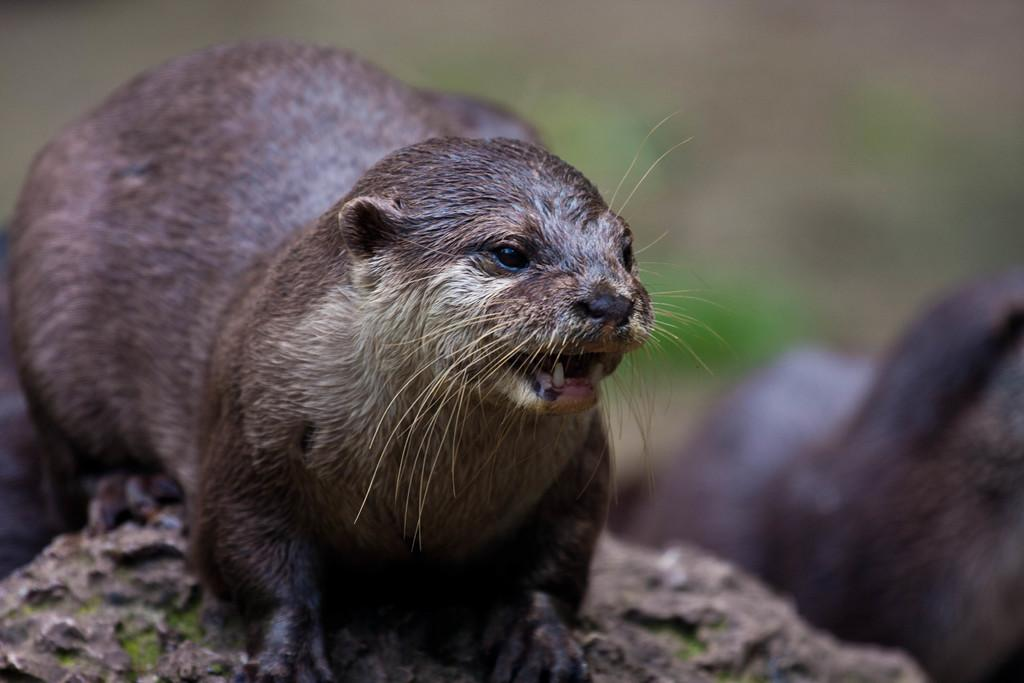What is the main subject of the image? There is an animal on a rock in the image. Can you describe the setting of the image? The background of the image is blurred. What type of attraction can be seen in the background of the image? There is no attraction visible in the image; the background is blurred. What type of rule does the frog enforce on the rock in the image? There is no frog present in the image, and therefore no rule enforcement can be determined. 